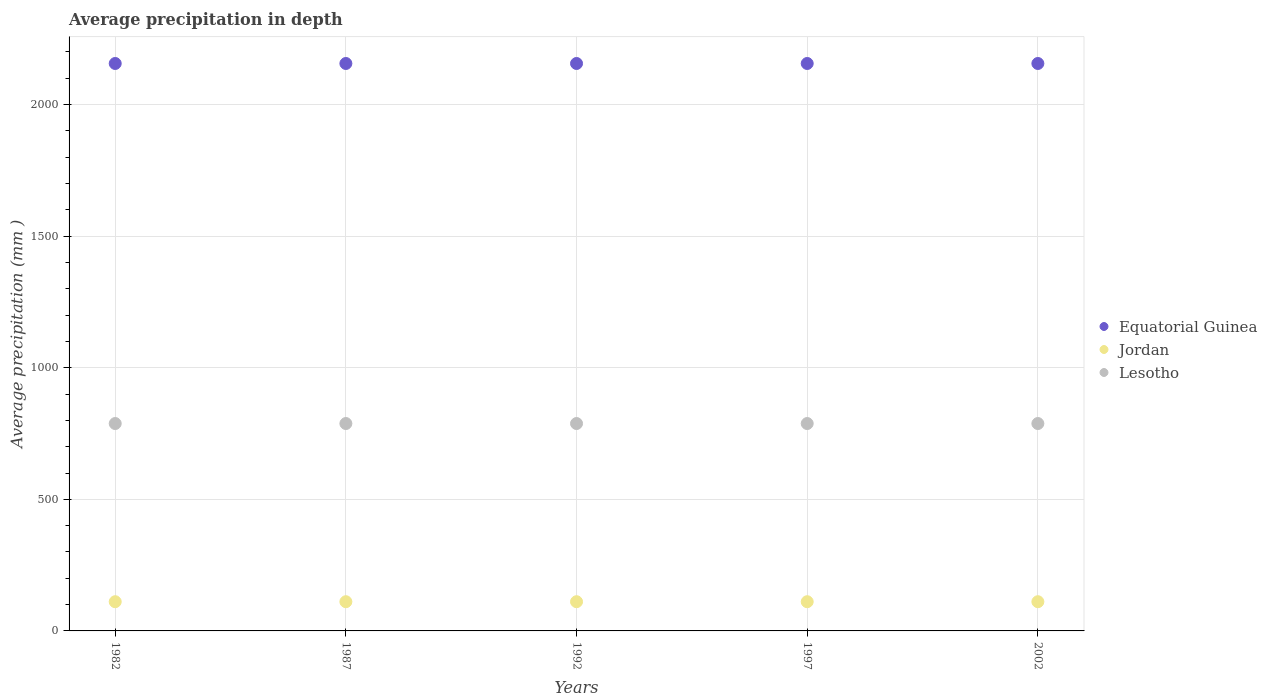What is the average precipitation in Equatorial Guinea in 1992?
Provide a succinct answer. 2156. Across all years, what is the maximum average precipitation in Jordan?
Offer a very short reply. 111. Across all years, what is the minimum average precipitation in Equatorial Guinea?
Make the answer very short. 2156. In which year was the average precipitation in Lesotho maximum?
Provide a succinct answer. 1982. What is the total average precipitation in Equatorial Guinea in the graph?
Offer a very short reply. 1.08e+04. What is the difference between the average precipitation in Lesotho in 1982 and that in 1997?
Offer a very short reply. 0. What is the difference between the average precipitation in Equatorial Guinea in 1992 and the average precipitation in Lesotho in 1997?
Ensure brevity in your answer.  1368. What is the average average precipitation in Jordan per year?
Your response must be concise. 111. In the year 1987, what is the difference between the average precipitation in Jordan and average precipitation in Lesotho?
Provide a succinct answer. -677. In how many years, is the average precipitation in Equatorial Guinea greater than 1600 mm?
Offer a very short reply. 5. What is the ratio of the average precipitation in Lesotho in 1997 to that in 2002?
Offer a terse response. 1. Is the average precipitation in Lesotho in 1997 less than that in 2002?
Keep it short and to the point. No. Is the difference between the average precipitation in Jordan in 1982 and 2002 greater than the difference between the average precipitation in Lesotho in 1982 and 2002?
Your answer should be compact. No. What is the difference between the highest and the lowest average precipitation in Lesotho?
Provide a short and direct response. 0. In how many years, is the average precipitation in Jordan greater than the average average precipitation in Jordan taken over all years?
Give a very brief answer. 0. Is the sum of the average precipitation in Equatorial Guinea in 1987 and 2002 greater than the maximum average precipitation in Lesotho across all years?
Give a very brief answer. Yes. Is it the case that in every year, the sum of the average precipitation in Lesotho and average precipitation in Jordan  is greater than the average precipitation in Equatorial Guinea?
Give a very brief answer. No. How many dotlines are there?
Give a very brief answer. 3. How many years are there in the graph?
Your response must be concise. 5. Does the graph contain any zero values?
Your response must be concise. No. What is the title of the graph?
Ensure brevity in your answer.  Average precipitation in depth. Does "Middle East & North Africa (all income levels)" appear as one of the legend labels in the graph?
Keep it short and to the point. No. What is the label or title of the Y-axis?
Provide a short and direct response. Average precipitation (mm ). What is the Average precipitation (mm ) in Equatorial Guinea in 1982?
Your response must be concise. 2156. What is the Average precipitation (mm ) in Jordan in 1982?
Keep it short and to the point. 111. What is the Average precipitation (mm ) of Lesotho in 1982?
Provide a short and direct response. 788. What is the Average precipitation (mm ) of Equatorial Guinea in 1987?
Your response must be concise. 2156. What is the Average precipitation (mm ) in Jordan in 1987?
Ensure brevity in your answer.  111. What is the Average precipitation (mm ) of Lesotho in 1987?
Offer a terse response. 788. What is the Average precipitation (mm ) in Equatorial Guinea in 1992?
Provide a succinct answer. 2156. What is the Average precipitation (mm ) in Jordan in 1992?
Provide a succinct answer. 111. What is the Average precipitation (mm ) in Lesotho in 1992?
Keep it short and to the point. 788. What is the Average precipitation (mm ) in Equatorial Guinea in 1997?
Ensure brevity in your answer.  2156. What is the Average precipitation (mm ) of Jordan in 1997?
Your answer should be very brief. 111. What is the Average precipitation (mm ) in Lesotho in 1997?
Provide a short and direct response. 788. What is the Average precipitation (mm ) in Equatorial Guinea in 2002?
Make the answer very short. 2156. What is the Average precipitation (mm ) of Jordan in 2002?
Your answer should be compact. 111. What is the Average precipitation (mm ) of Lesotho in 2002?
Offer a very short reply. 788. Across all years, what is the maximum Average precipitation (mm ) in Equatorial Guinea?
Ensure brevity in your answer.  2156. Across all years, what is the maximum Average precipitation (mm ) in Jordan?
Offer a terse response. 111. Across all years, what is the maximum Average precipitation (mm ) of Lesotho?
Your response must be concise. 788. Across all years, what is the minimum Average precipitation (mm ) in Equatorial Guinea?
Give a very brief answer. 2156. Across all years, what is the minimum Average precipitation (mm ) in Jordan?
Keep it short and to the point. 111. Across all years, what is the minimum Average precipitation (mm ) of Lesotho?
Your response must be concise. 788. What is the total Average precipitation (mm ) of Equatorial Guinea in the graph?
Your response must be concise. 1.08e+04. What is the total Average precipitation (mm ) in Jordan in the graph?
Offer a very short reply. 555. What is the total Average precipitation (mm ) in Lesotho in the graph?
Offer a very short reply. 3940. What is the difference between the Average precipitation (mm ) of Equatorial Guinea in 1982 and that in 1987?
Offer a terse response. 0. What is the difference between the Average precipitation (mm ) in Jordan in 1982 and that in 1987?
Your response must be concise. 0. What is the difference between the Average precipitation (mm ) of Lesotho in 1982 and that in 1987?
Keep it short and to the point. 0. What is the difference between the Average precipitation (mm ) of Jordan in 1982 and that in 1992?
Your response must be concise. 0. What is the difference between the Average precipitation (mm ) of Lesotho in 1982 and that in 1992?
Your answer should be very brief. 0. What is the difference between the Average precipitation (mm ) in Equatorial Guinea in 1982 and that in 1997?
Make the answer very short. 0. What is the difference between the Average precipitation (mm ) of Lesotho in 1982 and that in 1997?
Give a very brief answer. 0. What is the difference between the Average precipitation (mm ) in Equatorial Guinea in 1982 and that in 2002?
Give a very brief answer. 0. What is the difference between the Average precipitation (mm ) of Jordan in 1982 and that in 2002?
Your answer should be very brief. 0. What is the difference between the Average precipitation (mm ) of Equatorial Guinea in 1987 and that in 1992?
Your response must be concise. 0. What is the difference between the Average precipitation (mm ) of Lesotho in 1987 and that in 1992?
Give a very brief answer. 0. What is the difference between the Average precipitation (mm ) in Equatorial Guinea in 1987 and that in 1997?
Make the answer very short. 0. What is the difference between the Average precipitation (mm ) in Jordan in 1987 and that in 2002?
Your answer should be compact. 0. What is the difference between the Average precipitation (mm ) in Equatorial Guinea in 1992 and that in 1997?
Offer a very short reply. 0. What is the difference between the Average precipitation (mm ) in Lesotho in 1992 and that in 1997?
Provide a short and direct response. 0. What is the difference between the Average precipitation (mm ) of Equatorial Guinea in 1992 and that in 2002?
Give a very brief answer. 0. What is the difference between the Average precipitation (mm ) of Jordan in 1992 and that in 2002?
Keep it short and to the point. 0. What is the difference between the Average precipitation (mm ) of Lesotho in 1997 and that in 2002?
Ensure brevity in your answer.  0. What is the difference between the Average precipitation (mm ) in Equatorial Guinea in 1982 and the Average precipitation (mm ) in Jordan in 1987?
Your response must be concise. 2045. What is the difference between the Average precipitation (mm ) in Equatorial Guinea in 1982 and the Average precipitation (mm ) in Lesotho in 1987?
Provide a short and direct response. 1368. What is the difference between the Average precipitation (mm ) of Jordan in 1982 and the Average precipitation (mm ) of Lesotho in 1987?
Provide a short and direct response. -677. What is the difference between the Average precipitation (mm ) of Equatorial Guinea in 1982 and the Average precipitation (mm ) of Jordan in 1992?
Offer a very short reply. 2045. What is the difference between the Average precipitation (mm ) of Equatorial Guinea in 1982 and the Average precipitation (mm ) of Lesotho in 1992?
Give a very brief answer. 1368. What is the difference between the Average precipitation (mm ) of Jordan in 1982 and the Average precipitation (mm ) of Lesotho in 1992?
Offer a very short reply. -677. What is the difference between the Average precipitation (mm ) of Equatorial Guinea in 1982 and the Average precipitation (mm ) of Jordan in 1997?
Provide a succinct answer. 2045. What is the difference between the Average precipitation (mm ) of Equatorial Guinea in 1982 and the Average precipitation (mm ) of Lesotho in 1997?
Your answer should be very brief. 1368. What is the difference between the Average precipitation (mm ) of Jordan in 1982 and the Average precipitation (mm ) of Lesotho in 1997?
Provide a short and direct response. -677. What is the difference between the Average precipitation (mm ) of Equatorial Guinea in 1982 and the Average precipitation (mm ) of Jordan in 2002?
Ensure brevity in your answer.  2045. What is the difference between the Average precipitation (mm ) of Equatorial Guinea in 1982 and the Average precipitation (mm ) of Lesotho in 2002?
Your answer should be very brief. 1368. What is the difference between the Average precipitation (mm ) of Jordan in 1982 and the Average precipitation (mm ) of Lesotho in 2002?
Keep it short and to the point. -677. What is the difference between the Average precipitation (mm ) of Equatorial Guinea in 1987 and the Average precipitation (mm ) of Jordan in 1992?
Provide a succinct answer. 2045. What is the difference between the Average precipitation (mm ) in Equatorial Guinea in 1987 and the Average precipitation (mm ) in Lesotho in 1992?
Provide a succinct answer. 1368. What is the difference between the Average precipitation (mm ) of Jordan in 1987 and the Average precipitation (mm ) of Lesotho in 1992?
Make the answer very short. -677. What is the difference between the Average precipitation (mm ) of Equatorial Guinea in 1987 and the Average precipitation (mm ) of Jordan in 1997?
Keep it short and to the point. 2045. What is the difference between the Average precipitation (mm ) in Equatorial Guinea in 1987 and the Average precipitation (mm ) in Lesotho in 1997?
Ensure brevity in your answer.  1368. What is the difference between the Average precipitation (mm ) of Jordan in 1987 and the Average precipitation (mm ) of Lesotho in 1997?
Offer a terse response. -677. What is the difference between the Average precipitation (mm ) in Equatorial Guinea in 1987 and the Average precipitation (mm ) in Jordan in 2002?
Offer a terse response. 2045. What is the difference between the Average precipitation (mm ) of Equatorial Guinea in 1987 and the Average precipitation (mm ) of Lesotho in 2002?
Provide a succinct answer. 1368. What is the difference between the Average precipitation (mm ) in Jordan in 1987 and the Average precipitation (mm ) in Lesotho in 2002?
Your response must be concise. -677. What is the difference between the Average precipitation (mm ) in Equatorial Guinea in 1992 and the Average precipitation (mm ) in Jordan in 1997?
Offer a terse response. 2045. What is the difference between the Average precipitation (mm ) of Equatorial Guinea in 1992 and the Average precipitation (mm ) of Lesotho in 1997?
Your answer should be very brief. 1368. What is the difference between the Average precipitation (mm ) in Jordan in 1992 and the Average precipitation (mm ) in Lesotho in 1997?
Your answer should be very brief. -677. What is the difference between the Average precipitation (mm ) in Equatorial Guinea in 1992 and the Average precipitation (mm ) in Jordan in 2002?
Offer a terse response. 2045. What is the difference between the Average precipitation (mm ) in Equatorial Guinea in 1992 and the Average precipitation (mm ) in Lesotho in 2002?
Provide a succinct answer. 1368. What is the difference between the Average precipitation (mm ) in Jordan in 1992 and the Average precipitation (mm ) in Lesotho in 2002?
Your response must be concise. -677. What is the difference between the Average precipitation (mm ) of Equatorial Guinea in 1997 and the Average precipitation (mm ) of Jordan in 2002?
Your answer should be compact. 2045. What is the difference between the Average precipitation (mm ) in Equatorial Guinea in 1997 and the Average precipitation (mm ) in Lesotho in 2002?
Ensure brevity in your answer.  1368. What is the difference between the Average precipitation (mm ) of Jordan in 1997 and the Average precipitation (mm ) of Lesotho in 2002?
Keep it short and to the point. -677. What is the average Average precipitation (mm ) of Equatorial Guinea per year?
Offer a terse response. 2156. What is the average Average precipitation (mm ) in Jordan per year?
Offer a terse response. 111. What is the average Average precipitation (mm ) of Lesotho per year?
Provide a short and direct response. 788. In the year 1982, what is the difference between the Average precipitation (mm ) in Equatorial Guinea and Average precipitation (mm ) in Jordan?
Your answer should be very brief. 2045. In the year 1982, what is the difference between the Average precipitation (mm ) in Equatorial Guinea and Average precipitation (mm ) in Lesotho?
Offer a very short reply. 1368. In the year 1982, what is the difference between the Average precipitation (mm ) in Jordan and Average precipitation (mm ) in Lesotho?
Keep it short and to the point. -677. In the year 1987, what is the difference between the Average precipitation (mm ) in Equatorial Guinea and Average precipitation (mm ) in Jordan?
Offer a very short reply. 2045. In the year 1987, what is the difference between the Average precipitation (mm ) of Equatorial Guinea and Average precipitation (mm ) of Lesotho?
Make the answer very short. 1368. In the year 1987, what is the difference between the Average precipitation (mm ) in Jordan and Average precipitation (mm ) in Lesotho?
Keep it short and to the point. -677. In the year 1992, what is the difference between the Average precipitation (mm ) of Equatorial Guinea and Average precipitation (mm ) of Jordan?
Offer a very short reply. 2045. In the year 1992, what is the difference between the Average precipitation (mm ) of Equatorial Guinea and Average precipitation (mm ) of Lesotho?
Your answer should be very brief. 1368. In the year 1992, what is the difference between the Average precipitation (mm ) in Jordan and Average precipitation (mm ) in Lesotho?
Your answer should be very brief. -677. In the year 1997, what is the difference between the Average precipitation (mm ) of Equatorial Guinea and Average precipitation (mm ) of Jordan?
Keep it short and to the point. 2045. In the year 1997, what is the difference between the Average precipitation (mm ) in Equatorial Guinea and Average precipitation (mm ) in Lesotho?
Keep it short and to the point. 1368. In the year 1997, what is the difference between the Average precipitation (mm ) in Jordan and Average precipitation (mm ) in Lesotho?
Offer a terse response. -677. In the year 2002, what is the difference between the Average precipitation (mm ) in Equatorial Guinea and Average precipitation (mm ) in Jordan?
Make the answer very short. 2045. In the year 2002, what is the difference between the Average precipitation (mm ) in Equatorial Guinea and Average precipitation (mm ) in Lesotho?
Your answer should be very brief. 1368. In the year 2002, what is the difference between the Average precipitation (mm ) in Jordan and Average precipitation (mm ) in Lesotho?
Ensure brevity in your answer.  -677. What is the ratio of the Average precipitation (mm ) of Lesotho in 1982 to that in 1987?
Give a very brief answer. 1. What is the ratio of the Average precipitation (mm ) of Jordan in 1982 to that in 1997?
Provide a short and direct response. 1. What is the ratio of the Average precipitation (mm ) of Jordan in 1987 to that in 1992?
Provide a short and direct response. 1. What is the ratio of the Average precipitation (mm ) of Equatorial Guinea in 1987 to that in 1997?
Offer a very short reply. 1. What is the ratio of the Average precipitation (mm ) in Lesotho in 1987 to that in 1997?
Offer a terse response. 1. What is the ratio of the Average precipitation (mm ) in Jordan in 1987 to that in 2002?
Ensure brevity in your answer.  1. What is the ratio of the Average precipitation (mm ) of Lesotho in 1987 to that in 2002?
Your answer should be compact. 1. What is the ratio of the Average precipitation (mm ) of Equatorial Guinea in 1992 to that in 1997?
Your answer should be very brief. 1. What is the ratio of the Average precipitation (mm ) of Lesotho in 1992 to that in 1997?
Your answer should be very brief. 1. What is the ratio of the Average precipitation (mm ) of Equatorial Guinea in 1992 to that in 2002?
Provide a short and direct response. 1. What is the ratio of the Average precipitation (mm ) of Jordan in 1992 to that in 2002?
Provide a succinct answer. 1. What is the ratio of the Average precipitation (mm ) in Equatorial Guinea in 1997 to that in 2002?
Provide a succinct answer. 1. What is the ratio of the Average precipitation (mm ) in Jordan in 1997 to that in 2002?
Keep it short and to the point. 1. What is the difference between the highest and the second highest Average precipitation (mm ) of Jordan?
Ensure brevity in your answer.  0. What is the difference between the highest and the lowest Average precipitation (mm ) of Equatorial Guinea?
Give a very brief answer. 0. 